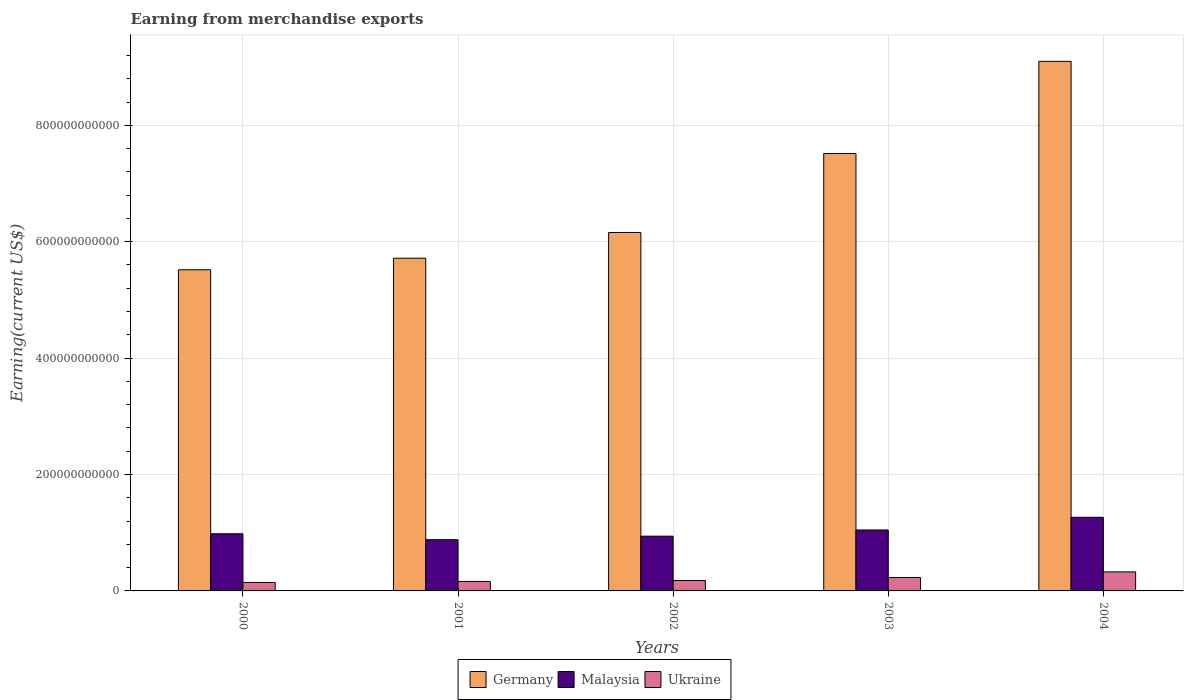How many different coloured bars are there?
Provide a short and direct response. 3. How many groups of bars are there?
Offer a terse response. 5. How many bars are there on the 5th tick from the right?
Provide a short and direct response. 3. What is the amount earned from merchandise exports in Malaysia in 2004?
Give a very brief answer. 1.27e+11. Across all years, what is the maximum amount earned from merchandise exports in Germany?
Your response must be concise. 9.10e+11. Across all years, what is the minimum amount earned from merchandise exports in Germany?
Offer a terse response. 5.52e+11. In which year was the amount earned from merchandise exports in Ukraine maximum?
Keep it short and to the point. 2004. What is the total amount earned from merchandise exports in Malaysia in the graph?
Keep it short and to the point. 5.12e+11. What is the difference between the amount earned from merchandise exports in Germany in 2000 and that in 2002?
Make the answer very short. -6.40e+1. What is the difference between the amount earned from merchandise exports in Germany in 2001 and the amount earned from merchandise exports in Malaysia in 2004?
Make the answer very short. 4.45e+11. What is the average amount earned from merchandise exports in Germany per year?
Provide a succinct answer. 6.80e+11. In the year 2001, what is the difference between the amount earned from merchandise exports in Malaysia and amount earned from merchandise exports in Germany?
Make the answer very short. -4.84e+11. What is the ratio of the amount earned from merchandise exports in Ukraine in 2001 to that in 2004?
Offer a terse response. 0.5. What is the difference between the highest and the second highest amount earned from merchandise exports in Ukraine?
Offer a very short reply. 9.60e+09. What is the difference between the highest and the lowest amount earned from merchandise exports in Ukraine?
Your answer should be very brief. 1.81e+1. In how many years, is the amount earned from merchandise exports in Ukraine greater than the average amount earned from merchandise exports in Ukraine taken over all years?
Your response must be concise. 2. What does the 3rd bar from the left in 2000 represents?
Your answer should be very brief. Ukraine. What does the 2nd bar from the right in 2001 represents?
Offer a very short reply. Malaysia. Is it the case that in every year, the sum of the amount earned from merchandise exports in Malaysia and amount earned from merchandise exports in Ukraine is greater than the amount earned from merchandise exports in Germany?
Offer a terse response. No. How many bars are there?
Offer a terse response. 15. Are all the bars in the graph horizontal?
Provide a short and direct response. No. How many years are there in the graph?
Offer a very short reply. 5. What is the difference between two consecutive major ticks on the Y-axis?
Keep it short and to the point. 2.00e+11. Are the values on the major ticks of Y-axis written in scientific E-notation?
Make the answer very short. No. Does the graph contain any zero values?
Your answer should be compact. No. Does the graph contain grids?
Give a very brief answer. Yes. How many legend labels are there?
Offer a terse response. 3. What is the title of the graph?
Make the answer very short. Earning from merchandise exports. What is the label or title of the Y-axis?
Your answer should be compact. Earning(current US$). What is the Earning(current US$) of Germany in 2000?
Your answer should be very brief. 5.52e+11. What is the Earning(current US$) in Malaysia in 2000?
Ensure brevity in your answer.  9.82e+1. What is the Earning(current US$) of Ukraine in 2000?
Offer a very short reply. 1.46e+1. What is the Earning(current US$) of Germany in 2001?
Your answer should be very brief. 5.72e+11. What is the Earning(current US$) in Malaysia in 2001?
Offer a very short reply. 8.80e+1. What is the Earning(current US$) of Ukraine in 2001?
Provide a succinct answer. 1.63e+1. What is the Earning(current US$) of Germany in 2002?
Ensure brevity in your answer.  6.16e+11. What is the Earning(current US$) of Malaysia in 2002?
Ensure brevity in your answer.  9.41e+1. What is the Earning(current US$) in Ukraine in 2002?
Make the answer very short. 1.80e+1. What is the Earning(current US$) of Germany in 2003?
Your answer should be compact. 7.52e+11. What is the Earning(current US$) of Malaysia in 2003?
Keep it short and to the point. 1.05e+11. What is the Earning(current US$) in Ukraine in 2003?
Your response must be concise. 2.31e+1. What is the Earning(current US$) of Germany in 2004?
Offer a very short reply. 9.10e+11. What is the Earning(current US$) in Malaysia in 2004?
Your response must be concise. 1.27e+11. What is the Earning(current US$) of Ukraine in 2004?
Offer a very short reply. 3.27e+1. Across all years, what is the maximum Earning(current US$) of Germany?
Provide a succinct answer. 9.10e+11. Across all years, what is the maximum Earning(current US$) in Malaysia?
Your answer should be very brief. 1.27e+11. Across all years, what is the maximum Earning(current US$) in Ukraine?
Offer a terse response. 3.27e+1. Across all years, what is the minimum Earning(current US$) of Germany?
Provide a short and direct response. 5.52e+11. Across all years, what is the minimum Earning(current US$) in Malaysia?
Offer a terse response. 8.80e+1. Across all years, what is the minimum Earning(current US$) of Ukraine?
Your answer should be compact. 1.46e+1. What is the total Earning(current US$) in Germany in the graph?
Your answer should be compact. 3.40e+12. What is the total Earning(current US$) of Malaysia in the graph?
Your response must be concise. 5.12e+11. What is the total Earning(current US$) of Ukraine in the graph?
Offer a terse response. 1.05e+11. What is the difference between the Earning(current US$) in Germany in 2000 and that in 2001?
Make the answer very short. -1.98e+1. What is the difference between the Earning(current US$) of Malaysia in 2000 and that in 2001?
Offer a terse response. 1.02e+1. What is the difference between the Earning(current US$) of Ukraine in 2000 and that in 2001?
Give a very brief answer. -1.69e+09. What is the difference between the Earning(current US$) of Germany in 2000 and that in 2002?
Make the answer very short. -6.40e+1. What is the difference between the Earning(current US$) of Malaysia in 2000 and that in 2002?
Offer a terse response. 4.17e+09. What is the difference between the Earning(current US$) of Ukraine in 2000 and that in 2002?
Provide a succinct answer. -3.38e+09. What is the difference between the Earning(current US$) of Germany in 2000 and that in 2003?
Offer a terse response. -2.00e+11. What is the difference between the Earning(current US$) of Malaysia in 2000 and that in 2003?
Ensure brevity in your answer.  -6.48e+09. What is the difference between the Earning(current US$) in Ukraine in 2000 and that in 2003?
Your response must be concise. -8.49e+09. What is the difference between the Earning(current US$) of Germany in 2000 and that in 2004?
Offer a very short reply. -3.58e+11. What is the difference between the Earning(current US$) of Malaysia in 2000 and that in 2004?
Give a very brief answer. -2.83e+1. What is the difference between the Earning(current US$) in Ukraine in 2000 and that in 2004?
Offer a terse response. -1.81e+1. What is the difference between the Earning(current US$) of Germany in 2001 and that in 2002?
Make the answer very short. -4.42e+1. What is the difference between the Earning(current US$) in Malaysia in 2001 and that in 2002?
Your response must be concise. -6.05e+09. What is the difference between the Earning(current US$) in Ukraine in 2001 and that in 2002?
Make the answer very short. -1.69e+09. What is the difference between the Earning(current US$) in Germany in 2001 and that in 2003?
Your response must be concise. -1.80e+11. What is the difference between the Earning(current US$) in Malaysia in 2001 and that in 2003?
Make the answer very short. -1.67e+1. What is the difference between the Earning(current US$) in Ukraine in 2001 and that in 2003?
Provide a short and direct response. -6.80e+09. What is the difference between the Earning(current US$) in Germany in 2001 and that in 2004?
Offer a terse response. -3.38e+11. What is the difference between the Earning(current US$) of Malaysia in 2001 and that in 2004?
Provide a succinct answer. -3.85e+1. What is the difference between the Earning(current US$) in Ukraine in 2001 and that in 2004?
Provide a succinct answer. -1.64e+1. What is the difference between the Earning(current US$) in Germany in 2002 and that in 2003?
Your answer should be very brief. -1.36e+11. What is the difference between the Earning(current US$) in Malaysia in 2002 and that in 2003?
Offer a terse response. -1.06e+1. What is the difference between the Earning(current US$) in Ukraine in 2002 and that in 2003?
Make the answer very short. -5.11e+09. What is the difference between the Earning(current US$) in Germany in 2002 and that in 2004?
Provide a succinct answer. -2.94e+11. What is the difference between the Earning(current US$) in Malaysia in 2002 and that in 2004?
Provide a short and direct response. -3.25e+1. What is the difference between the Earning(current US$) of Ukraine in 2002 and that in 2004?
Offer a very short reply. -1.47e+1. What is the difference between the Earning(current US$) of Germany in 2003 and that in 2004?
Offer a very short reply. -1.58e+11. What is the difference between the Earning(current US$) of Malaysia in 2003 and that in 2004?
Provide a short and direct response. -2.18e+1. What is the difference between the Earning(current US$) in Ukraine in 2003 and that in 2004?
Offer a terse response. -9.60e+09. What is the difference between the Earning(current US$) in Germany in 2000 and the Earning(current US$) in Malaysia in 2001?
Offer a very short reply. 4.64e+11. What is the difference between the Earning(current US$) in Germany in 2000 and the Earning(current US$) in Ukraine in 2001?
Your answer should be compact. 5.36e+11. What is the difference between the Earning(current US$) in Malaysia in 2000 and the Earning(current US$) in Ukraine in 2001?
Give a very brief answer. 8.20e+1. What is the difference between the Earning(current US$) in Germany in 2000 and the Earning(current US$) in Malaysia in 2002?
Ensure brevity in your answer.  4.58e+11. What is the difference between the Earning(current US$) of Germany in 2000 and the Earning(current US$) of Ukraine in 2002?
Provide a succinct answer. 5.34e+11. What is the difference between the Earning(current US$) of Malaysia in 2000 and the Earning(current US$) of Ukraine in 2002?
Your response must be concise. 8.03e+1. What is the difference between the Earning(current US$) in Germany in 2000 and the Earning(current US$) in Malaysia in 2003?
Your answer should be very brief. 4.47e+11. What is the difference between the Earning(current US$) in Germany in 2000 and the Earning(current US$) in Ukraine in 2003?
Provide a short and direct response. 5.29e+11. What is the difference between the Earning(current US$) of Malaysia in 2000 and the Earning(current US$) of Ukraine in 2003?
Give a very brief answer. 7.52e+1. What is the difference between the Earning(current US$) in Germany in 2000 and the Earning(current US$) in Malaysia in 2004?
Your answer should be very brief. 4.25e+11. What is the difference between the Earning(current US$) of Germany in 2000 and the Earning(current US$) of Ukraine in 2004?
Make the answer very short. 5.19e+11. What is the difference between the Earning(current US$) of Malaysia in 2000 and the Earning(current US$) of Ukraine in 2004?
Ensure brevity in your answer.  6.56e+1. What is the difference between the Earning(current US$) in Germany in 2001 and the Earning(current US$) in Malaysia in 2002?
Ensure brevity in your answer.  4.78e+11. What is the difference between the Earning(current US$) in Germany in 2001 and the Earning(current US$) in Ukraine in 2002?
Offer a very short reply. 5.54e+11. What is the difference between the Earning(current US$) in Malaysia in 2001 and the Earning(current US$) in Ukraine in 2002?
Keep it short and to the point. 7.00e+1. What is the difference between the Earning(current US$) of Germany in 2001 and the Earning(current US$) of Malaysia in 2003?
Give a very brief answer. 4.67e+11. What is the difference between the Earning(current US$) of Germany in 2001 and the Earning(current US$) of Ukraine in 2003?
Your answer should be very brief. 5.49e+11. What is the difference between the Earning(current US$) in Malaysia in 2001 and the Earning(current US$) in Ukraine in 2003?
Keep it short and to the point. 6.49e+1. What is the difference between the Earning(current US$) of Germany in 2001 and the Earning(current US$) of Malaysia in 2004?
Offer a terse response. 4.45e+11. What is the difference between the Earning(current US$) in Germany in 2001 and the Earning(current US$) in Ukraine in 2004?
Provide a short and direct response. 5.39e+11. What is the difference between the Earning(current US$) in Malaysia in 2001 and the Earning(current US$) in Ukraine in 2004?
Provide a short and direct response. 5.53e+1. What is the difference between the Earning(current US$) of Germany in 2002 and the Earning(current US$) of Malaysia in 2003?
Provide a succinct answer. 5.11e+11. What is the difference between the Earning(current US$) in Germany in 2002 and the Earning(current US$) in Ukraine in 2003?
Your response must be concise. 5.93e+11. What is the difference between the Earning(current US$) of Malaysia in 2002 and the Earning(current US$) of Ukraine in 2003?
Provide a short and direct response. 7.10e+1. What is the difference between the Earning(current US$) of Germany in 2002 and the Earning(current US$) of Malaysia in 2004?
Give a very brief answer. 4.89e+11. What is the difference between the Earning(current US$) in Germany in 2002 and the Earning(current US$) in Ukraine in 2004?
Your answer should be compact. 5.83e+11. What is the difference between the Earning(current US$) in Malaysia in 2002 and the Earning(current US$) in Ukraine in 2004?
Make the answer very short. 6.14e+1. What is the difference between the Earning(current US$) in Germany in 2003 and the Earning(current US$) in Malaysia in 2004?
Your answer should be very brief. 6.25e+11. What is the difference between the Earning(current US$) of Germany in 2003 and the Earning(current US$) of Ukraine in 2004?
Offer a very short reply. 7.19e+11. What is the difference between the Earning(current US$) of Malaysia in 2003 and the Earning(current US$) of Ukraine in 2004?
Provide a short and direct response. 7.20e+1. What is the average Earning(current US$) in Germany per year?
Your answer should be very brief. 6.80e+11. What is the average Earning(current US$) of Malaysia per year?
Offer a very short reply. 1.02e+11. What is the average Earning(current US$) in Ukraine per year?
Keep it short and to the point. 2.09e+1. In the year 2000, what is the difference between the Earning(current US$) of Germany and Earning(current US$) of Malaysia?
Your answer should be compact. 4.54e+11. In the year 2000, what is the difference between the Earning(current US$) in Germany and Earning(current US$) in Ukraine?
Provide a succinct answer. 5.37e+11. In the year 2000, what is the difference between the Earning(current US$) of Malaysia and Earning(current US$) of Ukraine?
Provide a short and direct response. 8.37e+1. In the year 2001, what is the difference between the Earning(current US$) of Germany and Earning(current US$) of Malaysia?
Make the answer very short. 4.84e+11. In the year 2001, what is the difference between the Earning(current US$) of Germany and Earning(current US$) of Ukraine?
Offer a very short reply. 5.55e+11. In the year 2001, what is the difference between the Earning(current US$) in Malaysia and Earning(current US$) in Ukraine?
Your answer should be very brief. 7.17e+1. In the year 2002, what is the difference between the Earning(current US$) of Germany and Earning(current US$) of Malaysia?
Keep it short and to the point. 5.22e+11. In the year 2002, what is the difference between the Earning(current US$) of Germany and Earning(current US$) of Ukraine?
Offer a very short reply. 5.98e+11. In the year 2002, what is the difference between the Earning(current US$) in Malaysia and Earning(current US$) in Ukraine?
Give a very brief answer. 7.61e+1. In the year 2003, what is the difference between the Earning(current US$) of Germany and Earning(current US$) of Malaysia?
Ensure brevity in your answer.  6.47e+11. In the year 2003, what is the difference between the Earning(current US$) of Germany and Earning(current US$) of Ukraine?
Your answer should be compact. 7.28e+11. In the year 2003, what is the difference between the Earning(current US$) of Malaysia and Earning(current US$) of Ukraine?
Give a very brief answer. 8.16e+1. In the year 2004, what is the difference between the Earning(current US$) of Germany and Earning(current US$) of Malaysia?
Your answer should be very brief. 7.83e+11. In the year 2004, what is the difference between the Earning(current US$) in Germany and Earning(current US$) in Ukraine?
Provide a short and direct response. 8.77e+11. In the year 2004, what is the difference between the Earning(current US$) of Malaysia and Earning(current US$) of Ukraine?
Provide a short and direct response. 9.38e+1. What is the ratio of the Earning(current US$) of Germany in 2000 to that in 2001?
Offer a very short reply. 0.97. What is the ratio of the Earning(current US$) in Malaysia in 2000 to that in 2001?
Your response must be concise. 1.12. What is the ratio of the Earning(current US$) in Ukraine in 2000 to that in 2001?
Keep it short and to the point. 0.9. What is the ratio of the Earning(current US$) in Germany in 2000 to that in 2002?
Provide a short and direct response. 0.9. What is the ratio of the Earning(current US$) of Malaysia in 2000 to that in 2002?
Offer a terse response. 1.04. What is the ratio of the Earning(current US$) of Ukraine in 2000 to that in 2002?
Ensure brevity in your answer.  0.81. What is the ratio of the Earning(current US$) in Germany in 2000 to that in 2003?
Ensure brevity in your answer.  0.73. What is the ratio of the Earning(current US$) of Malaysia in 2000 to that in 2003?
Make the answer very short. 0.94. What is the ratio of the Earning(current US$) of Ukraine in 2000 to that in 2003?
Offer a terse response. 0.63. What is the ratio of the Earning(current US$) in Germany in 2000 to that in 2004?
Your answer should be very brief. 0.61. What is the ratio of the Earning(current US$) in Malaysia in 2000 to that in 2004?
Ensure brevity in your answer.  0.78. What is the ratio of the Earning(current US$) in Ukraine in 2000 to that in 2004?
Offer a terse response. 0.45. What is the ratio of the Earning(current US$) of Germany in 2001 to that in 2002?
Provide a short and direct response. 0.93. What is the ratio of the Earning(current US$) in Malaysia in 2001 to that in 2002?
Give a very brief answer. 0.94. What is the ratio of the Earning(current US$) in Ukraine in 2001 to that in 2002?
Ensure brevity in your answer.  0.91. What is the ratio of the Earning(current US$) in Germany in 2001 to that in 2003?
Keep it short and to the point. 0.76. What is the ratio of the Earning(current US$) in Malaysia in 2001 to that in 2003?
Make the answer very short. 0.84. What is the ratio of the Earning(current US$) of Ukraine in 2001 to that in 2003?
Provide a short and direct response. 0.71. What is the ratio of the Earning(current US$) in Germany in 2001 to that in 2004?
Your response must be concise. 0.63. What is the ratio of the Earning(current US$) of Malaysia in 2001 to that in 2004?
Provide a succinct answer. 0.7. What is the ratio of the Earning(current US$) of Ukraine in 2001 to that in 2004?
Your response must be concise. 0.5. What is the ratio of the Earning(current US$) of Germany in 2002 to that in 2003?
Your response must be concise. 0.82. What is the ratio of the Earning(current US$) of Malaysia in 2002 to that in 2003?
Your answer should be compact. 0.9. What is the ratio of the Earning(current US$) of Ukraine in 2002 to that in 2003?
Offer a very short reply. 0.78. What is the ratio of the Earning(current US$) in Germany in 2002 to that in 2004?
Make the answer very short. 0.68. What is the ratio of the Earning(current US$) of Malaysia in 2002 to that in 2004?
Make the answer very short. 0.74. What is the ratio of the Earning(current US$) in Ukraine in 2002 to that in 2004?
Offer a terse response. 0.55. What is the ratio of the Earning(current US$) in Germany in 2003 to that in 2004?
Provide a succinct answer. 0.83. What is the ratio of the Earning(current US$) of Malaysia in 2003 to that in 2004?
Provide a short and direct response. 0.83. What is the ratio of the Earning(current US$) of Ukraine in 2003 to that in 2004?
Offer a very short reply. 0.71. What is the difference between the highest and the second highest Earning(current US$) of Germany?
Offer a terse response. 1.58e+11. What is the difference between the highest and the second highest Earning(current US$) in Malaysia?
Provide a short and direct response. 2.18e+1. What is the difference between the highest and the second highest Earning(current US$) in Ukraine?
Provide a succinct answer. 9.60e+09. What is the difference between the highest and the lowest Earning(current US$) of Germany?
Provide a succinct answer. 3.58e+11. What is the difference between the highest and the lowest Earning(current US$) of Malaysia?
Give a very brief answer. 3.85e+1. What is the difference between the highest and the lowest Earning(current US$) in Ukraine?
Give a very brief answer. 1.81e+1. 